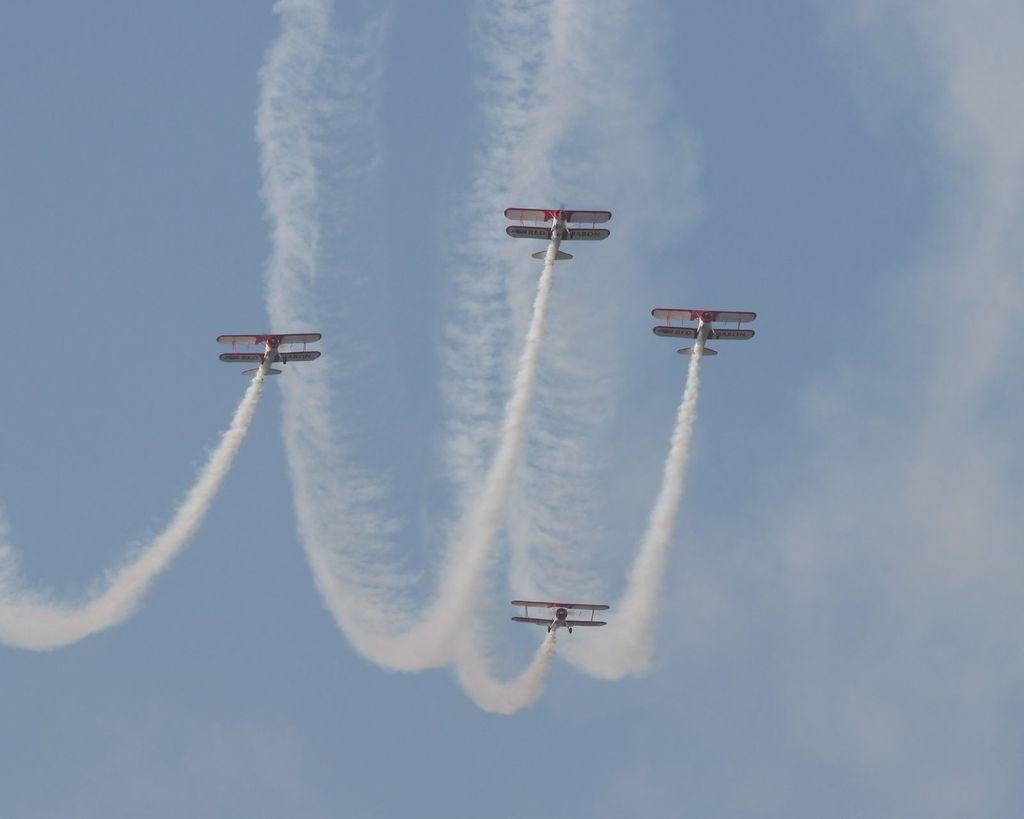Please provide a concise description of this image. In this picture we can see four aircraft flying in the sky. Behind we can see white smoke. 